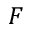<formula> <loc_0><loc_0><loc_500><loc_500>F</formula> 